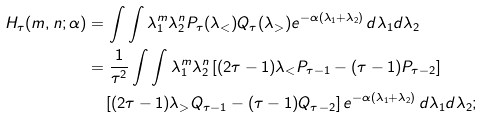<formula> <loc_0><loc_0><loc_500><loc_500>H _ { \tau } ( m , n ; \alpha ) & = \int \int \lambda _ { 1 } ^ { m } \lambda _ { 2 } ^ { n } P _ { \tau } ( \lambda _ { < } ) Q _ { \tau } ( \lambda _ { > } ) e ^ { - \alpha ( \lambda _ { 1 } + \lambda _ { 2 } ) } \, d \lambda _ { 1 } d \lambda _ { 2 } \\ & = \frac { 1 } { \tau ^ { 2 } } \int \int \lambda _ { 1 } ^ { m } \lambda _ { 2 } ^ { n } \left [ ( 2 \tau - 1 ) \lambda _ { < } P _ { \tau - 1 } - ( \tau - 1 ) P _ { \tau - 2 } \right ] \\ & \quad \left [ ( 2 \tau - 1 ) \lambda _ { > } Q _ { \tau - 1 } - ( \tau - 1 ) Q _ { \tau - 2 } \right ] e ^ { - \alpha ( \lambda _ { 1 } + \lambda _ { 2 } ) } \, d \lambda _ { 1 } d \lambda _ { 2 } ;</formula> 